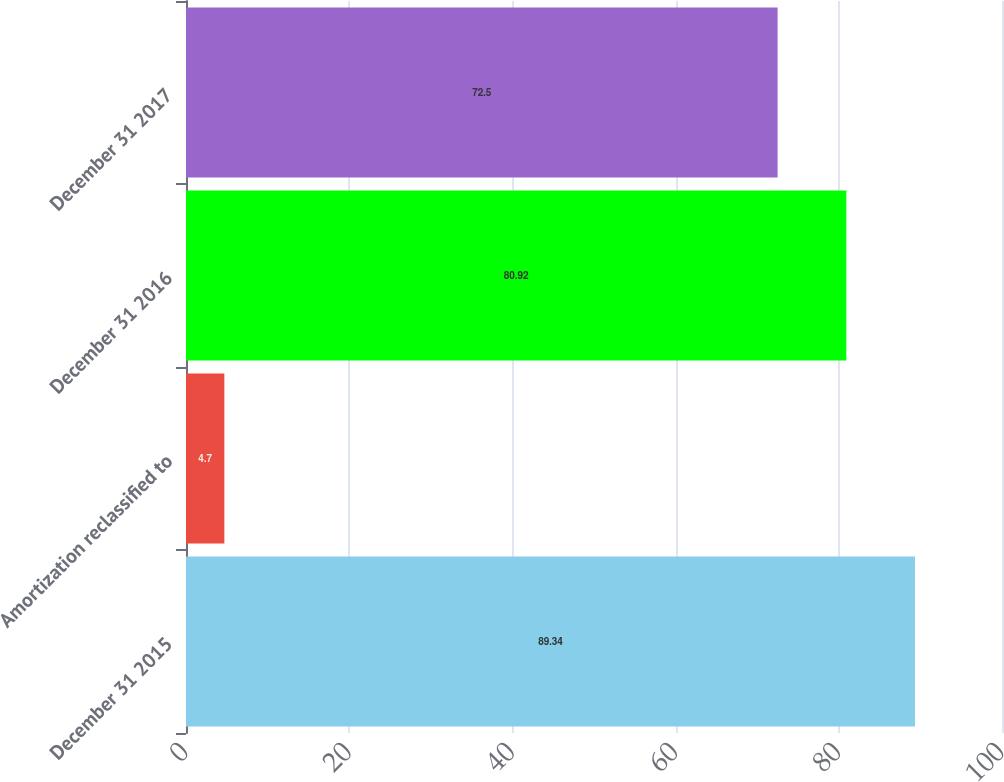Convert chart. <chart><loc_0><loc_0><loc_500><loc_500><bar_chart><fcel>December 31 2015<fcel>Amortization reclassified to<fcel>December 31 2016<fcel>December 31 2017<nl><fcel>89.34<fcel>4.7<fcel>80.92<fcel>72.5<nl></chart> 